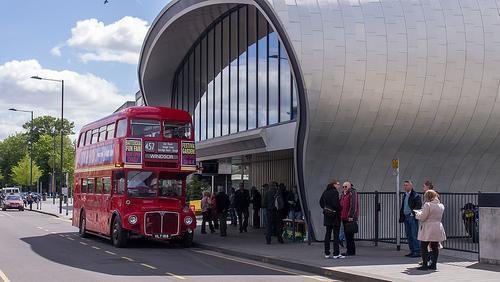How many buses are shown?
Give a very brief answer. 1. 